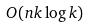Convert formula to latex. <formula><loc_0><loc_0><loc_500><loc_500>O ( n k \log k )</formula> 